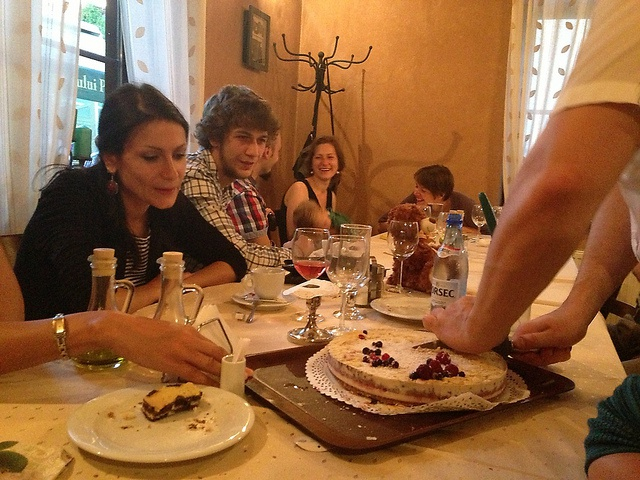Describe the objects in this image and their specific colors. I can see people in lightgray, maroon, brown, and tan tones, dining table in lightgray, olive, tan, and maroon tones, people in lightgray, black, maroon, and brown tones, people in lightgray, maroon, brown, gray, and black tones, and cake in lightgray, tan, brown, maroon, and black tones in this image. 